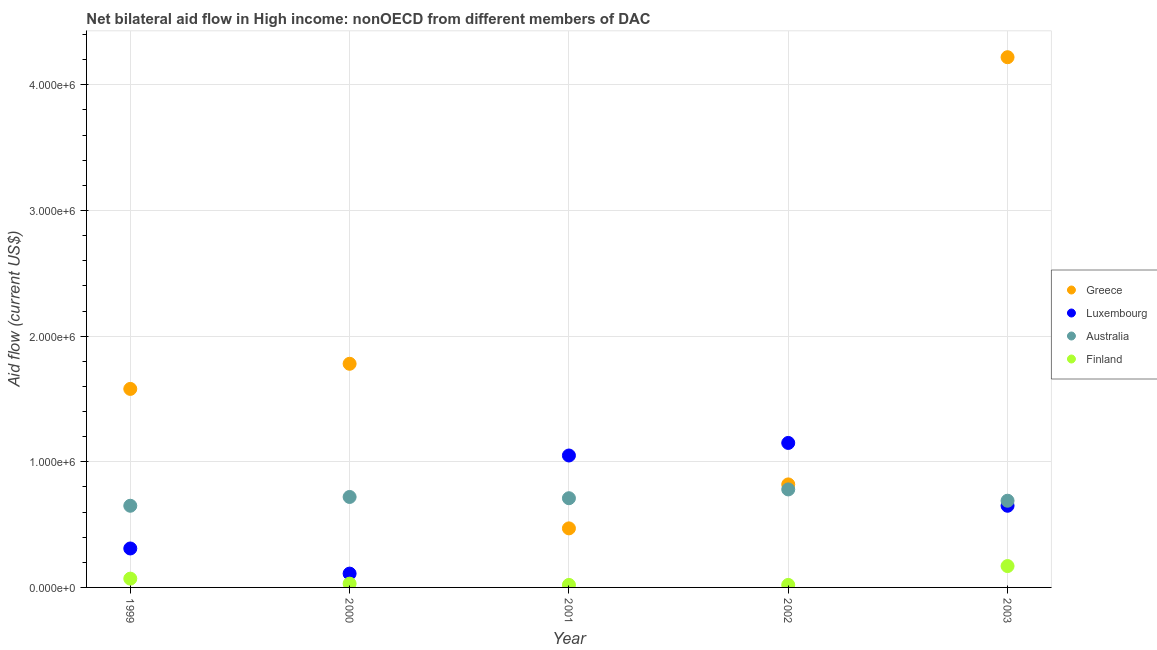How many different coloured dotlines are there?
Keep it short and to the point. 4. Is the number of dotlines equal to the number of legend labels?
Your answer should be very brief. Yes. What is the amount of aid given by australia in 2003?
Provide a short and direct response. 6.90e+05. Across all years, what is the maximum amount of aid given by australia?
Your response must be concise. 7.80e+05. Across all years, what is the minimum amount of aid given by australia?
Your answer should be very brief. 6.50e+05. In which year was the amount of aid given by greece maximum?
Make the answer very short. 2003. In which year was the amount of aid given by greece minimum?
Offer a very short reply. 2001. What is the total amount of aid given by australia in the graph?
Your response must be concise. 3.55e+06. What is the difference between the amount of aid given by australia in 1999 and that in 2001?
Ensure brevity in your answer.  -6.00e+04. What is the difference between the amount of aid given by luxembourg in 2001 and the amount of aid given by finland in 2002?
Ensure brevity in your answer.  1.03e+06. What is the average amount of aid given by greece per year?
Offer a very short reply. 1.77e+06. In the year 2002, what is the difference between the amount of aid given by greece and amount of aid given by luxembourg?
Offer a terse response. -3.30e+05. What is the ratio of the amount of aid given by finland in 2000 to that in 2001?
Ensure brevity in your answer.  1.5. Is the amount of aid given by greece in 2002 less than that in 2003?
Give a very brief answer. Yes. What is the difference between the highest and the second highest amount of aid given by greece?
Ensure brevity in your answer.  2.44e+06. What is the difference between the highest and the lowest amount of aid given by australia?
Give a very brief answer. 1.30e+05. Is the sum of the amount of aid given by greece in 2002 and 2003 greater than the maximum amount of aid given by australia across all years?
Offer a terse response. Yes. Is it the case that in every year, the sum of the amount of aid given by greece and amount of aid given by luxembourg is greater than the amount of aid given by australia?
Give a very brief answer. Yes. Does the amount of aid given by finland monotonically increase over the years?
Your response must be concise. No. Is the amount of aid given by finland strictly greater than the amount of aid given by australia over the years?
Provide a succinct answer. No. How many years are there in the graph?
Provide a short and direct response. 5. Are the values on the major ticks of Y-axis written in scientific E-notation?
Keep it short and to the point. Yes. Does the graph contain any zero values?
Give a very brief answer. No. Does the graph contain grids?
Your response must be concise. Yes. Where does the legend appear in the graph?
Ensure brevity in your answer.  Center right. What is the title of the graph?
Provide a succinct answer. Net bilateral aid flow in High income: nonOECD from different members of DAC. Does "UNDP" appear as one of the legend labels in the graph?
Provide a succinct answer. No. What is the label or title of the Y-axis?
Give a very brief answer. Aid flow (current US$). What is the Aid flow (current US$) in Greece in 1999?
Keep it short and to the point. 1.58e+06. What is the Aid flow (current US$) in Luxembourg in 1999?
Give a very brief answer. 3.10e+05. What is the Aid flow (current US$) in Australia in 1999?
Give a very brief answer. 6.50e+05. What is the Aid flow (current US$) in Finland in 1999?
Keep it short and to the point. 7.00e+04. What is the Aid flow (current US$) of Greece in 2000?
Provide a short and direct response. 1.78e+06. What is the Aid flow (current US$) in Luxembourg in 2000?
Offer a very short reply. 1.10e+05. What is the Aid flow (current US$) in Australia in 2000?
Your answer should be very brief. 7.20e+05. What is the Aid flow (current US$) of Finland in 2000?
Give a very brief answer. 3.00e+04. What is the Aid flow (current US$) in Greece in 2001?
Give a very brief answer. 4.70e+05. What is the Aid flow (current US$) of Luxembourg in 2001?
Offer a very short reply. 1.05e+06. What is the Aid flow (current US$) in Australia in 2001?
Offer a very short reply. 7.10e+05. What is the Aid flow (current US$) of Finland in 2001?
Ensure brevity in your answer.  2.00e+04. What is the Aid flow (current US$) of Greece in 2002?
Provide a short and direct response. 8.20e+05. What is the Aid flow (current US$) of Luxembourg in 2002?
Give a very brief answer. 1.15e+06. What is the Aid flow (current US$) of Australia in 2002?
Make the answer very short. 7.80e+05. What is the Aid flow (current US$) of Greece in 2003?
Offer a terse response. 4.22e+06. What is the Aid flow (current US$) of Luxembourg in 2003?
Provide a succinct answer. 6.50e+05. What is the Aid flow (current US$) in Australia in 2003?
Provide a succinct answer. 6.90e+05. Across all years, what is the maximum Aid flow (current US$) of Greece?
Your response must be concise. 4.22e+06. Across all years, what is the maximum Aid flow (current US$) of Luxembourg?
Provide a succinct answer. 1.15e+06. Across all years, what is the maximum Aid flow (current US$) in Australia?
Your answer should be compact. 7.80e+05. Across all years, what is the minimum Aid flow (current US$) in Australia?
Ensure brevity in your answer.  6.50e+05. Across all years, what is the minimum Aid flow (current US$) of Finland?
Offer a terse response. 2.00e+04. What is the total Aid flow (current US$) of Greece in the graph?
Your answer should be compact. 8.87e+06. What is the total Aid flow (current US$) in Luxembourg in the graph?
Your response must be concise. 3.27e+06. What is the total Aid flow (current US$) of Australia in the graph?
Give a very brief answer. 3.55e+06. What is the total Aid flow (current US$) in Finland in the graph?
Give a very brief answer. 3.10e+05. What is the difference between the Aid flow (current US$) in Greece in 1999 and that in 2000?
Provide a short and direct response. -2.00e+05. What is the difference between the Aid flow (current US$) of Luxembourg in 1999 and that in 2000?
Ensure brevity in your answer.  2.00e+05. What is the difference between the Aid flow (current US$) of Finland in 1999 and that in 2000?
Your answer should be very brief. 4.00e+04. What is the difference between the Aid flow (current US$) in Greece in 1999 and that in 2001?
Provide a succinct answer. 1.11e+06. What is the difference between the Aid flow (current US$) in Luxembourg in 1999 and that in 2001?
Your response must be concise. -7.40e+05. What is the difference between the Aid flow (current US$) of Australia in 1999 and that in 2001?
Your answer should be compact. -6.00e+04. What is the difference between the Aid flow (current US$) of Finland in 1999 and that in 2001?
Provide a short and direct response. 5.00e+04. What is the difference between the Aid flow (current US$) in Greece in 1999 and that in 2002?
Your response must be concise. 7.60e+05. What is the difference between the Aid flow (current US$) in Luxembourg in 1999 and that in 2002?
Make the answer very short. -8.40e+05. What is the difference between the Aid flow (current US$) in Finland in 1999 and that in 2002?
Offer a terse response. 5.00e+04. What is the difference between the Aid flow (current US$) of Greece in 1999 and that in 2003?
Offer a very short reply. -2.64e+06. What is the difference between the Aid flow (current US$) in Luxembourg in 1999 and that in 2003?
Offer a very short reply. -3.40e+05. What is the difference between the Aid flow (current US$) in Greece in 2000 and that in 2001?
Keep it short and to the point. 1.31e+06. What is the difference between the Aid flow (current US$) in Luxembourg in 2000 and that in 2001?
Provide a short and direct response. -9.40e+05. What is the difference between the Aid flow (current US$) in Greece in 2000 and that in 2002?
Your answer should be very brief. 9.60e+05. What is the difference between the Aid flow (current US$) of Luxembourg in 2000 and that in 2002?
Make the answer very short. -1.04e+06. What is the difference between the Aid flow (current US$) of Australia in 2000 and that in 2002?
Provide a succinct answer. -6.00e+04. What is the difference between the Aid flow (current US$) of Greece in 2000 and that in 2003?
Give a very brief answer. -2.44e+06. What is the difference between the Aid flow (current US$) in Luxembourg in 2000 and that in 2003?
Your answer should be very brief. -5.40e+05. What is the difference between the Aid flow (current US$) of Australia in 2000 and that in 2003?
Offer a very short reply. 3.00e+04. What is the difference between the Aid flow (current US$) in Finland in 2000 and that in 2003?
Your answer should be compact. -1.40e+05. What is the difference between the Aid flow (current US$) of Greece in 2001 and that in 2002?
Your response must be concise. -3.50e+05. What is the difference between the Aid flow (current US$) in Luxembourg in 2001 and that in 2002?
Your answer should be very brief. -1.00e+05. What is the difference between the Aid flow (current US$) of Greece in 2001 and that in 2003?
Your response must be concise. -3.75e+06. What is the difference between the Aid flow (current US$) of Luxembourg in 2001 and that in 2003?
Offer a terse response. 4.00e+05. What is the difference between the Aid flow (current US$) in Finland in 2001 and that in 2003?
Give a very brief answer. -1.50e+05. What is the difference between the Aid flow (current US$) in Greece in 2002 and that in 2003?
Your answer should be compact. -3.40e+06. What is the difference between the Aid flow (current US$) of Luxembourg in 2002 and that in 2003?
Provide a short and direct response. 5.00e+05. What is the difference between the Aid flow (current US$) in Finland in 2002 and that in 2003?
Give a very brief answer. -1.50e+05. What is the difference between the Aid flow (current US$) of Greece in 1999 and the Aid flow (current US$) of Luxembourg in 2000?
Offer a very short reply. 1.47e+06. What is the difference between the Aid flow (current US$) in Greece in 1999 and the Aid flow (current US$) in Australia in 2000?
Make the answer very short. 8.60e+05. What is the difference between the Aid flow (current US$) of Greece in 1999 and the Aid flow (current US$) of Finland in 2000?
Offer a terse response. 1.55e+06. What is the difference between the Aid flow (current US$) in Luxembourg in 1999 and the Aid flow (current US$) in Australia in 2000?
Offer a very short reply. -4.10e+05. What is the difference between the Aid flow (current US$) in Luxembourg in 1999 and the Aid flow (current US$) in Finland in 2000?
Your response must be concise. 2.80e+05. What is the difference between the Aid flow (current US$) of Australia in 1999 and the Aid flow (current US$) of Finland in 2000?
Ensure brevity in your answer.  6.20e+05. What is the difference between the Aid flow (current US$) of Greece in 1999 and the Aid flow (current US$) of Luxembourg in 2001?
Your answer should be very brief. 5.30e+05. What is the difference between the Aid flow (current US$) in Greece in 1999 and the Aid flow (current US$) in Australia in 2001?
Make the answer very short. 8.70e+05. What is the difference between the Aid flow (current US$) of Greece in 1999 and the Aid flow (current US$) of Finland in 2001?
Give a very brief answer. 1.56e+06. What is the difference between the Aid flow (current US$) of Luxembourg in 1999 and the Aid flow (current US$) of Australia in 2001?
Your answer should be compact. -4.00e+05. What is the difference between the Aid flow (current US$) in Luxembourg in 1999 and the Aid flow (current US$) in Finland in 2001?
Provide a short and direct response. 2.90e+05. What is the difference between the Aid flow (current US$) in Australia in 1999 and the Aid flow (current US$) in Finland in 2001?
Provide a succinct answer. 6.30e+05. What is the difference between the Aid flow (current US$) of Greece in 1999 and the Aid flow (current US$) of Luxembourg in 2002?
Offer a very short reply. 4.30e+05. What is the difference between the Aid flow (current US$) of Greece in 1999 and the Aid flow (current US$) of Finland in 2002?
Your answer should be very brief. 1.56e+06. What is the difference between the Aid flow (current US$) of Luxembourg in 1999 and the Aid flow (current US$) of Australia in 2002?
Offer a very short reply. -4.70e+05. What is the difference between the Aid flow (current US$) of Australia in 1999 and the Aid flow (current US$) of Finland in 2002?
Your answer should be compact. 6.30e+05. What is the difference between the Aid flow (current US$) of Greece in 1999 and the Aid flow (current US$) of Luxembourg in 2003?
Offer a terse response. 9.30e+05. What is the difference between the Aid flow (current US$) in Greece in 1999 and the Aid flow (current US$) in Australia in 2003?
Keep it short and to the point. 8.90e+05. What is the difference between the Aid flow (current US$) in Greece in 1999 and the Aid flow (current US$) in Finland in 2003?
Your response must be concise. 1.41e+06. What is the difference between the Aid flow (current US$) of Luxembourg in 1999 and the Aid flow (current US$) of Australia in 2003?
Keep it short and to the point. -3.80e+05. What is the difference between the Aid flow (current US$) of Greece in 2000 and the Aid flow (current US$) of Luxembourg in 2001?
Provide a succinct answer. 7.30e+05. What is the difference between the Aid flow (current US$) in Greece in 2000 and the Aid flow (current US$) in Australia in 2001?
Your response must be concise. 1.07e+06. What is the difference between the Aid flow (current US$) in Greece in 2000 and the Aid flow (current US$) in Finland in 2001?
Offer a very short reply. 1.76e+06. What is the difference between the Aid flow (current US$) of Luxembourg in 2000 and the Aid flow (current US$) of Australia in 2001?
Offer a very short reply. -6.00e+05. What is the difference between the Aid flow (current US$) in Australia in 2000 and the Aid flow (current US$) in Finland in 2001?
Your answer should be compact. 7.00e+05. What is the difference between the Aid flow (current US$) in Greece in 2000 and the Aid flow (current US$) in Luxembourg in 2002?
Offer a very short reply. 6.30e+05. What is the difference between the Aid flow (current US$) of Greece in 2000 and the Aid flow (current US$) of Finland in 2002?
Offer a very short reply. 1.76e+06. What is the difference between the Aid flow (current US$) in Luxembourg in 2000 and the Aid flow (current US$) in Australia in 2002?
Keep it short and to the point. -6.70e+05. What is the difference between the Aid flow (current US$) in Luxembourg in 2000 and the Aid flow (current US$) in Finland in 2002?
Provide a short and direct response. 9.00e+04. What is the difference between the Aid flow (current US$) of Greece in 2000 and the Aid flow (current US$) of Luxembourg in 2003?
Your response must be concise. 1.13e+06. What is the difference between the Aid flow (current US$) in Greece in 2000 and the Aid flow (current US$) in Australia in 2003?
Your answer should be very brief. 1.09e+06. What is the difference between the Aid flow (current US$) in Greece in 2000 and the Aid flow (current US$) in Finland in 2003?
Give a very brief answer. 1.61e+06. What is the difference between the Aid flow (current US$) in Luxembourg in 2000 and the Aid flow (current US$) in Australia in 2003?
Make the answer very short. -5.80e+05. What is the difference between the Aid flow (current US$) of Luxembourg in 2000 and the Aid flow (current US$) of Finland in 2003?
Make the answer very short. -6.00e+04. What is the difference between the Aid flow (current US$) of Australia in 2000 and the Aid flow (current US$) of Finland in 2003?
Make the answer very short. 5.50e+05. What is the difference between the Aid flow (current US$) of Greece in 2001 and the Aid flow (current US$) of Luxembourg in 2002?
Provide a succinct answer. -6.80e+05. What is the difference between the Aid flow (current US$) in Greece in 2001 and the Aid flow (current US$) in Australia in 2002?
Make the answer very short. -3.10e+05. What is the difference between the Aid flow (current US$) of Greece in 2001 and the Aid flow (current US$) of Finland in 2002?
Your answer should be very brief. 4.50e+05. What is the difference between the Aid flow (current US$) in Luxembourg in 2001 and the Aid flow (current US$) in Australia in 2002?
Your answer should be very brief. 2.70e+05. What is the difference between the Aid flow (current US$) in Luxembourg in 2001 and the Aid flow (current US$) in Finland in 2002?
Your answer should be very brief. 1.03e+06. What is the difference between the Aid flow (current US$) of Australia in 2001 and the Aid flow (current US$) of Finland in 2002?
Your answer should be compact. 6.90e+05. What is the difference between the Aid flow (current US$) in Greece in 2001 and the Aid flow (current US$) in Australia in 2003?
Offer a very short reply. -2.20e+05. What is the difference between the Aid flow (current US$) of Luxembourg in 2001 and the Aid flow (current US$) of Finland in 2003?
Offer a terse response. 8.80e+05. What is the difference between the Aid flow (current US$) in Australia in 2001 and the Aid flow (current US$) in Finland in 2003?
Your answer should be very brief. 5.40e+05. What is the difference between the Aid flow (current US$) in Greece in 2002 and the Aid flow (current US$) in Luxembourg in 2003?
Give a very brief answer. 1.70e+05. What is the difference between the Aid flow (current US$) in Greece in 2002 and the Aid flow (current US$) in Finland in 2003?
Your response must be concise. 6.50e+05. What is the difference between the Aid flow (current US$) in Luxembourg in 2002 and the Aid flow (current US$) in Australia in 2003?
Give a very brief answer. 4.60e+05. What is the difference between the Aid flow (current US$) of Luxembourg in 2002 and the Aid flow (current US$) of Finland in 2003?
Offer a terse response. 9.80e+05. What is the average Aid flow (current US$) in Greece per year?
Provide a succinct answer. 1.77e+06. What is the average Aid flow (current US$) of Luxembourg per year?
Make the answer very short. 6.54e+05. What is the average Aid flow (current US$) of Australia per year?
Your answer should be very brief. 7.10e+05. What is the average Aid flow (current US$) of Finland per year?
Provide a short and direct response. 6.20e+04. In the year 1999, what is the difference between the Aid flow (current US$) in Greece and Aid flow (current US$) in Luxembourg?
Offer a terse response. 1.27e+06. In the year 1999, what is the difference between the Aid flow (current US$) of Greece and Aid flow (current US$) of Australia?
Give a very brief answer. 9.30e+05. In the year 1999, what is the difference between the Aid flow (current US$) of Greece and Aid flow (current US$) of Finland?
Provide a succinct answer. 1.51e+06. In the year 1999, what is the difference between the Aid flow (current US$) of Luxembourg and Aid flow (current US$) of Finland?
Your answer should be compact. 2.40e+05. In the year 1999, what is the difference between the Aid flow (current US$) in Australia and Aid flow (current US$) in Finland?
Your response must be concise. 5.80e+05. In the year 2000, what is the difference between the Aid flow (current US$) in Greece and Aid flow (current US$) in Luxembourg?
Your response must be concise. 1.67e+06. In the year 2000, what is the difference between the Aid flow (current US$) of Greece and Aid flow (current US$) of Australia?
Make the answer very short. 1.06e+06. In the year 2000, what is the difference between the Aid flow (current US$) in Greece and Aid flow (current US$) in Finland?
Make the answer very short. 1.75e+06. In the year 2000, what is the difference between the Aid flow (current US$) in Luxembourg and Aid flow (current US$) in Australia?
Provide a succinct answer. -6.10e+05. In the year 2000, what is the difference between the Aid flow (current US$) in Australia and Aid flow (current US$) in Finland?
Make the answer very short. 6.90e+05. In the year 2001, what is the difference between the Aid flow (current US$) of Greece and Aid flow (current US$) of Luxembourg?
Ensure brevity in your answer.  -5.80e+05. In the year 2001, what is the difference between the Aid flow (current US$) of Greece and Aid flow (current US$) of Australia?
Ensure brevity in your answer.  -2.40e+05. In the year 2001, what is the difference between the Aid flow (current US$) in Greece and Aid flow (current US$) in Finland?
Your response must be concise. 4.50e+05. In the year 2001, what is the difference between the Aid flow (current US$) in Luxembourg and Aid flow (current US$) in Australia?
Your answer should be compact. 3.40e+05. In the year 2001, what is the difference between the Aid flow (current US$) in Luxembourg and Aid flow (current US$) in Finland?
Give a very brief answer. 1.03e+06. In the year 2001, what is the difference between the Aid flow (current US$) of Australia and Aid flow (current US$) of Finland?
Provide a succinct answer. 6.90e+05. In the year 2002, what is the difference between the Aid flow (current US$) in Greece and Aid flow (current US$) in Luxembourg?
Offer a terse response. -3.30e+05. In the year 2002, what is the difference between the Aid flow (current US$) in Greece and Aid flow (current US$) in Australia?
Provide a short and direct response. 4.00e+04. In the year 2002, what is the difference between the Aid flow (current US$) in Greece and Aid flow (current US$) in Finland?
Your response must be concise. 8.00e+05. In the year 2002, what is the difference between the Aid flow (current US$) of Luxembourg and Aid flow (current US$) of Australia?
Ensure brevity in your answer.  3.70e+05. In the year 2002, what is the difference between the Aid flow (current US$) in Luxembourg and Aid flow (current US$) in Finland?
Offer a very short reply. 1.13e+06. In the year 2002, what is the difference between the Aid flow (current US$) of Australia and Aid flow (current US$) of Finland?
Ensure brevity in your answer.  7.60e+05. In the year 2003, what is the difference between the Aid flow (current US$) of Greece and Aid flow (current US$) of Luxembourg?
Your answer should be compact. 3.57e+06. In the year 2003, what is the difference between the Aid flow (current US$) of Greece and Aid flow (current US$) of Australia?
Provide a short and direct response. 3.53e+06. In the year 2003, what is the difference between the Aid flow (current US$) of Greece and Aid flow (current US$) of Finland?
Provide a short and direct response. 4.05e+06. In the year 2003, what is the difference between the Aid flow (current US$) of Luxembourg and Aid flow (current US$) of Australia?
Ensure brevity in your answer.  -4.00e+04. In the year 2003, what is the difference between the Aid flow (current US$) of Australia and Aid flow (current US$) of Finland?
Offer a terse response. 5.20e+05. What is the ratio of the Aid flow (current US$) of Greece in 1999 to that in 2000?
Your answer should be compact. 0.89. What is the ratio of the Aid flow (current US$) of Luxembourg in 1999 to that in 2000?
Your response must be concise. 2.82. What is the ratio of the Aid flow (current US$) in Australia in 1999 to that in 2000?
Your response must be concise. 0.9. What is the ratio of the Aid flow (current US$) of Finland in 1999 to that in 2000?
Your answer should be compact. 2.33. What is the ratio of the Aid flow (current US$) in Greece in 1999 to that in 2001?
Keep it short and to the point. 3.36. What is the ratio of the Aid flow (current US$) in Luxembourg in 1999 to that in 2001?
Provide a succinct answer. 0.3. What is the ratio of the Aid flow (current US$) in Australia in 1999 to that in 2001?
Offer a terse response. 0.92. What is the ratio of the Aid flow (current US$) of Finland in 1999 to that in 2001?
Offer a very short reply. 3.5. What is the ratio of the Aid flow (current US$) in Greece in 1999 to that in 2002?
Offer a terse response. 1.93. What is the ratio of the Aid flow (current US$) in Luxembourg in 1999 to that in 2002?
Make the answer very short. 0.27. What is the ratio of the Aid flow (current US$) of Australia in 1999 to that in 2002?
Give a very brief answer. 0.83. What is the ratio of the Aid flow (current US$) in Finland in 1999 to that in 2002?
Your response must be concise. 3.5. What is the ratio of the Aid flow (current US$) in Greece in 1999 to that in 2003?
Give a very brief answer. 0.37. What is the ratio of the Aid flow (current US$) of Luxembourg in 1999 to that in 2003?
Your response must be concise. 0.48. What is the ratio of the Aid flow (current US$) of Australia in 1999 to that in 2003?
Offer a very short reply. 0.94. What is the ratio of the Aid flow (current US$) of Finland in 1999 to that in 2003?
Provide a short and direct response. 0.41. What is the ratio of the Aid flow (current US$) of Greece in 2000 to that in 2001?
Your answer should be compact. 3.79. What is the ratio of the Aid flow (current US$) of Luxembourg in 2000 to that in 2001?
Give a very brief answer. 0.1. What is the ratio of the Aid flow (current US$) of Australia in 2000 to that in 2001?
Offer a very short reply. 1.01. What is the ratio of the Aid flow (current US$) of Greece in 2000 to that in 2002?
Provide a succinct answer. 2.17. What is the ratio of the Aid flow (current US$) of Luxembourg in 2000 to that in 2002?
Ensure brevity in your answer.  0.1. What is the ratio of the Aid flow (current US$) of Greece in 2000 to that in 2003?
Your response must be concise. 0.42. What is the ratio of the Aid flow (current US$) of Luxembourg in 2000 to that in 2003?
Make the answer very short. 0.17. What is the ratio of the Aid flow (current US$) in Australia in 2000 to that in 2003?
Your answer should be compact. 1.04. What is the ratio of the Aid flow (current US$) in Finland in 2000 to that in 2003?
Keep it short and to the point. 0.18. What is the ratio of the Aid flow (current US$) in Greece in 2001 to that in 2002?
Ensure brevity in your answer.  0.57. What is the ratio of the Aid flow (current US$) of Australia in 2001 to that in 2002?
Offer a terse response. 0.91. What is the ratio of the Aid flow (current US$) of Greece in 2001 to that in 2003?
Your response must be concise. 0.11. What is the ratio of the Aid flow (current US$) in Luxembourg in 2001 to that in 2003?
Give a very brief answer. 1.62. What is the ratio of the Aid flow (current US$) of Finland in 2001 to that in 2003?
Provide a short and direct response. 0.12. What is the ratio of the Aid flow (current US$) of Greece in 2002 to that in 2003?
Your answer should be very brief. 0.19. What is the ratio of the Aid flow (current US$) in Luxembourg in 2002 to that in 2003?
Ensure brevity in your answer.  1.77. What is the ratio of the Aid flow (current US$) in Australia in 2002 to that in 2003?
Ensure brevity in your answer.  1.13. What is the ratio of the Aid flow (current US$) in Finland in 2002 to that in 2003?
Your answer should be compact. 0.12. What is the difference between the highest and the second highest Aid flow (current US$) of Greece?
Provide a succinct answer. 2.44e+06. What is the difference between the highest and the second highest Aid flow (current US$) in Luxembourg?
Ensure brevity in your answer.  1.00e+05. What is the difference between the highest and the second highest Aid flow (current US$) of Finland?
Offer a very short reply. 1.00e+05. What is the difference between the highest and the lowest Aid flow (current US$) in Greece?
Your answer should be compact. 3.75e+06. What is the difference between the highest and the lowest Aid flow (current US$) of Luxembourg?
Your response must be concise. 1.04e+06. What is the difference between the highest and the lowest Aid flow (current US$) in Finland?
Offer a very short reply. 1.50e+05. 